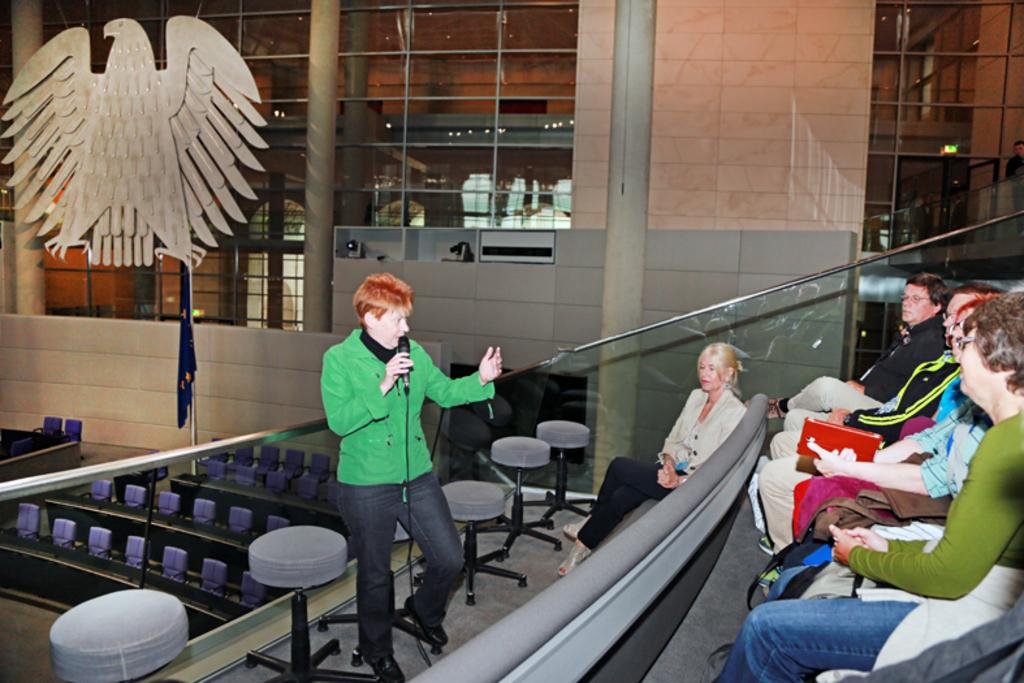Who is the main subject in the image? There is a woman in the image. What is the woman doing in the image? The woman is standing on the floor and holding a mic in her hands. What can be seen in the background of the image? There is a building visible in the image. What are the people in the image doing? There are people sitting on chairs in the image. What type of polish is the woman applying to her nails in the image? There is no indication in the image that the woman is applying polish to her nails; she is holding a mic and standing on the floor. 